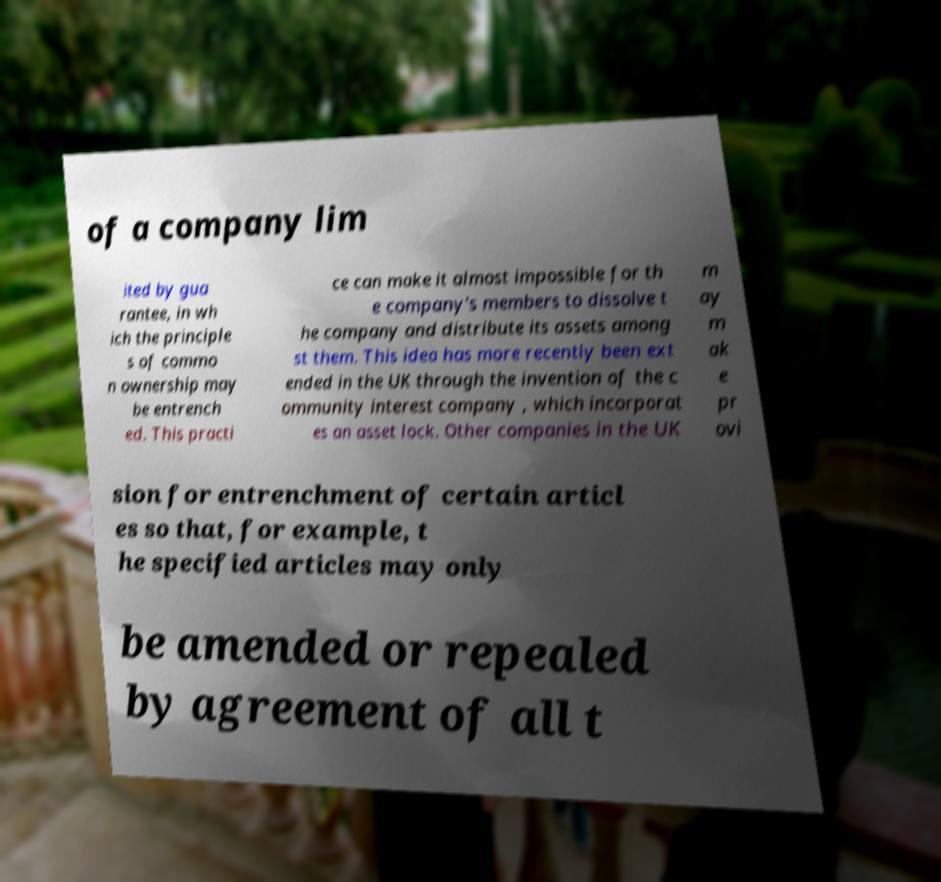There's text embedded in this image that I need extracted. Can you transcribe it verbatim? of a company lim ited by gua rantee, in wh ich the principle s of commo n ownership may be entrench ed. This practi ce can make it almost impossible for th e company's members to dissolve t he company and distribute its assets among st them. This idea has more recently been ext ended in the UK through the invention of the c ommunity interest company , which incorporat es an asset lock. Other companies in the UK m ay m ak e pr ovi sion for entrenchment of certain articl es so that, for example, t he specified articles may only be amended or repealed by agreement of all t 